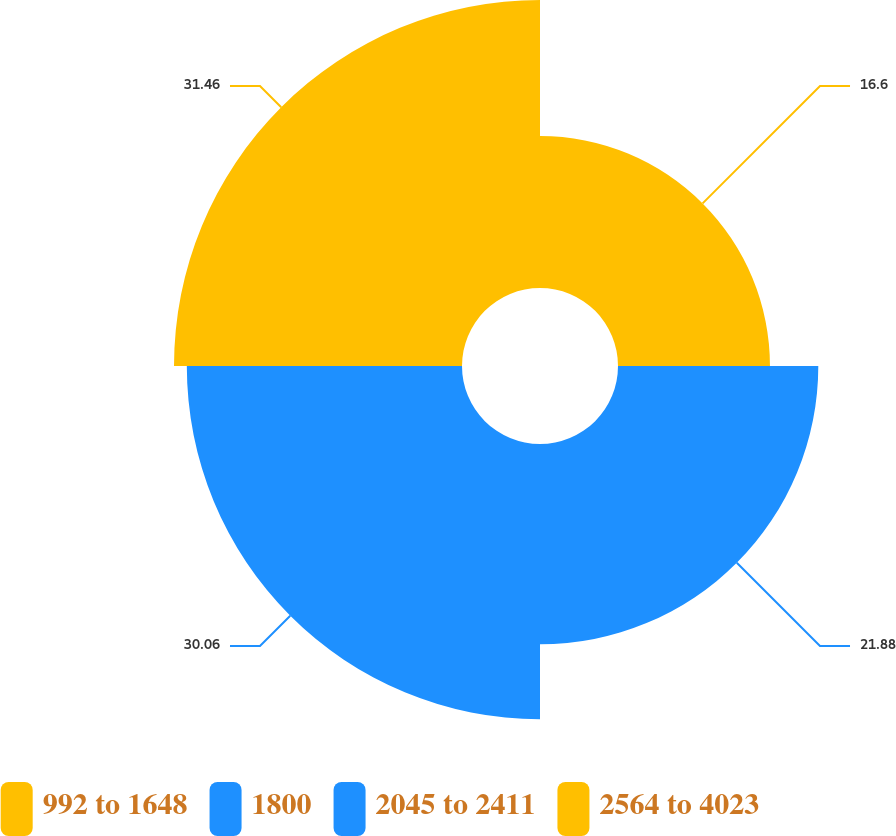Convert chart. <chart><loc_0><loc_0><loc_500><loc_500><pie_chart><fcel>992 to 1648<fcel>1800<fcel>2045 to 2411<fcel>2564 to 4023<nl><fcel>16.6%<fcel>21.88%<fcel>30.06%<fcel>31.46%<nl></chart> 